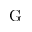Convert formula to latex. <formula><loc_0><loc_0><loc_500><loc_500>G</formula> 